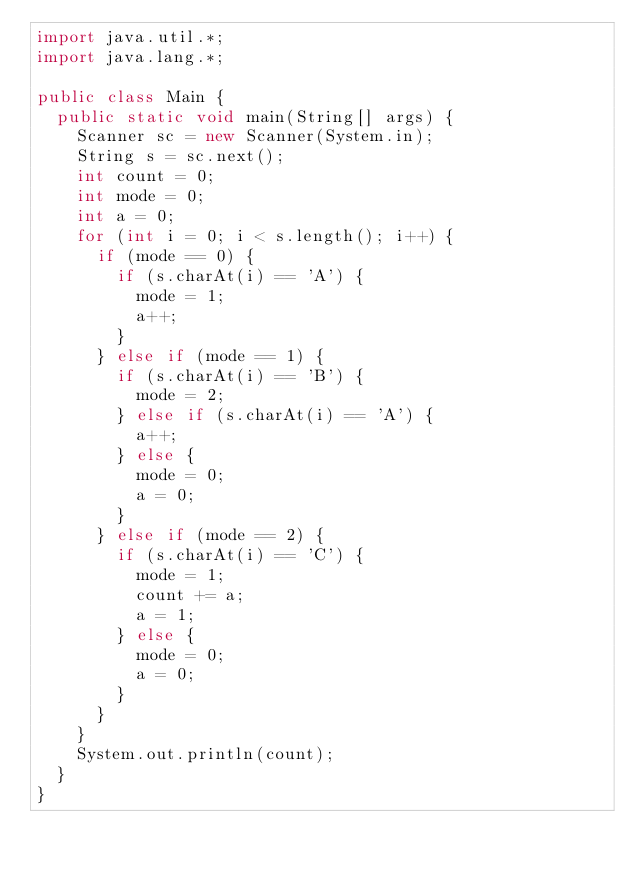Convert code to text. <code><loc_0><loc_0><loc_500><loc_500><_Java_>import java.util.*;
import java.lang.*;

public class Main {
	public static void main(String[] args) {
		Scanner sc = new Scanner(System.in);
		String s = sc.next();
		int count = 0;
		int mode = 0;
		int a = 0;
		for (int i = 0; i < s.length(); i++) {
			if (mode == 0) {
				if (s.charAt(i) == 'A') {
					mode = 1;
					a++;
				}
			} else if (mode == 1) {
				if (s.charAt(i) == 'B') {
					mode = 2;
				} else if (s.charAt(i) == 'A') {
					a++;
				} else {
					mode = 0;
					a = 0;
				}
			} else if (mode == 2) {
				if (s.charAt(i) == 'C') {
					mode = 1;
					count += a;
					a = 1;
				} else {
					mode = 0;
					a = 0;
				}
			}
		}
		System.out.println(count);
	}
}
</code> 